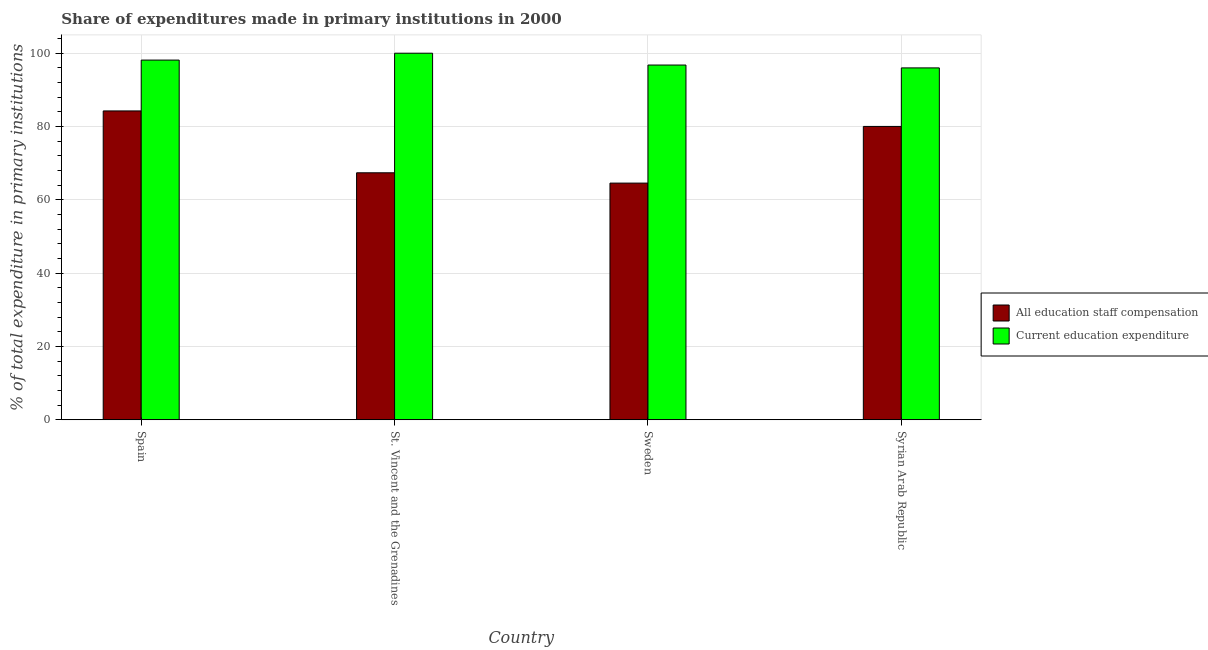Are the number of bars on each tick of the X-axis equal?
Your answer should be compact. Yes. What is the label of the 2nd group of bars from the left?
Provide a succinct answer. St. Vincent and the Grenadines. In how many cases, is the number of bars for a given country not equal to the number of legend labels?
Your answer should be very brief. 0. What is the expenditure in education in Spain?
Give a very brief answer. 98.12. Across all countries, what is the minimum expenditure in education?
Make the answer very short. 95.99. In which country was the expenditure in education maximum?
Give a very brief answer. St. Vincent and the Grenadines. In which country was the expenditure in education minimum?
Make the answer very short. Syrian Arab Republic. What is the total expenditure in staff compensation in the graph?
Your answer should be compact. 296.23. What is the difference between the expenditure in education in Spain and that in Sweden?
Make the answer very short. 1.35. What is the difference between the expenditure in staff compensation in St. Vincent and the Grenadines and the expenditure in education in Sweden?
Make the answer very short. -29.39. What is the average expenditure in staff compensation per country?
Keep it short and to the point. 74.06. What is the difference between the expenditure in education and expenditure in staff compensation in St. Vincent and the Grenadines?
Your response must be concise. 32.62. In how many countries, is the expenditure in education greater than 16 %?
Your answer should be very brief. 4. What is the ratio of the expenditure in staff compensation in St. Vincent and the Grenadines to that in Syrian Arab Republic?
Make the answer very short. 0.84. Is the expenditure in education in St. Vincent and the Grenadines less than that in Sweden?
Make the answer very short. No. Is the difference between the expenditure in education in Spain and Sweden greater than the difference between the expenditure in staff compensation in Spain and Sweden?
Provide a succinct answer. No. What is the difference between the highest and the second highest expenditure in staff compensation?
Offer a very short reply. 4.23. What is the difference between the highest and the lowest expenditure in staff compensation?
Make the answer very short. 19.69. In how many countries, is the expenditure in education greater than the average expenditure in education taken over all countries?
Ensure brevity in your answer.  2. What does the 1st bar from the left in Sweden represents?
Offer a very short reply. All education staff compensation. What does the 1st bar from the right in Spain represents?
Make the answer very short. Current education expenditure. Are the values on the major ticks of Y-axis written in scientific E-notation?
Your answer should be very brief. No. Where does the legend appear in the graph?
Provide a succinct answer. Center right. How many legend labels are there?
Keep it short and to the point. 2. What is the title of the graph?
Keep it short and to the point. Share of expenditures made in primary institutions in 2000. What is the label or title of the Y-axis?
Offer a very short reply. % of total expenditure in primary institutions. What is the % of total expenditure in primary institutions in All education staff compensation in Spain?
Ensure brevity in your answer.  84.26. What is the % of total expenditure in primary institutions in Current education expenditure in Spain?
Provide a succinct answer. 98.12. What is the % of total expenditure in primary institutions of All education staff compensation in St. Vincent and the Grenadines?
Your answer should be very brief. 67.38. What is the % of total expenditure in primary institutions of Current education expenditure in St. Vincent and the Grenadines?
Keep it short and to the point. 100. What is the % of total expenditure in primary institutions of All education staff compensation in Sweden?
Offer a very short reply. 64.57. What is the % of total expenditure in primary institutions in Current education expenditure in Sweden?
Your response must be concise. 96.77. What is the % of total expenditure in primary institutions in All education staff compensation in Syrian Arab Republic?
Provide a succinct answer. 80.03. What is the % of total expenditure in primary institutions of Current education expenditure in Syrian Arab Republic?
Offer a very short reply. 95.99. Across all countries, what is the maximum % of total expenditure in primary institutions in All education staff compensation?
Offer a terse response. 84.26. Across all countries, what is the minimum % of total expenditure in primary institutions in All education staff compensation?
Ensure brevity in your answer.  64.57. Across all countries, what is the minimum % of total expenditure in primary institutions in Current education expenditure?
Provide a short and direct response. 95.99. What is the total % of total expenditure in primary institutions of All education staff compensation in the graph?
Offer a terse response. 296.23. What is the total % of total expenditure in primary institutions in Current education expenditure in the graph?
Your response must be concise. 390.89. What is the difference between the % of total expenditure in primary institutions of All education staff compensation in Spain and that in St. Vincent and the Grenadines?
Give a very brief answer. 16.87. What is the difference between the % of total expenditure in primary institutions of Current education expenditure in Spain and that in St. Vincent and the Grenadines?
Your answer should be very brief. -1.88. What is the difference between the % of total expenditure in primary institutions of All education staff compensation in Spain and that in Sweden?
Keep it short and to the point. 19.69. What is the difference between the % of total expenditure in primary institutions of Current education expenditure in Spain and that in Sweden?
Provide a short and direct response. 1.35. What is the difference between the % of total expenditure in primary institutions in All education staff compensation in Spain and that in Syrian Arab Republic?
Your answer should be very brief. 4.23. What is the difference between the % of total expenditure in primary institutions in Current education expenditure in Spain and that in Syrian Arab Republic?
Keep it short and to the point. 2.13. What is the difference between the % of total expenditure in primary institutions in All education staff compensation in St. Vincent and the Grenadines and that in Sweden?
Keep it short and to the point. 2.81. What is the difference between the % of total expenditure in primary institutions in Current education expenditure in St. Vincent and the Grenadines and that in Sweden?
Ensure brevity in your answer.  3.23. What is the difference between the % of total expenditure in primary institutions of All education staff compensation in St. Vincent and the Grenadines and that in Syrian Arab Republic?
Provide a short and direct response. -12.65. What is the difference between the % of total expenditure in primary institutions in Current education expenditure in St. Vincent and the Grenadines and that in Syrian Arab Republic?
Provide a short and direct response. 4.01. What is the difference between the % of total expenditure in primary institutions in All education staff compensation in Sweden and that in Syrian Arab Republic?
Your answer should be very brief. -15.46. What is the difference between the % of total expenditure in primary institutions of Current education expenditure in Sweden and that in Syrian Arab Republic?
Offer a terse response. 0.78. What is the difference between the % of total expenditure in primary institutions in All education staff compensation in Spain and the % of total expenditure in primary institutions in Current education expenditure in St. Vincent and the Grenadines?
Ensure brevity in your answer.  -15.74. What is the difference between the % of total expenditure in primary institutions of All education staff compensation in Spain and the % of total expenditure in primary institutions of Current education expenditure in Sweden?
Make the answer very short. -12.52. What is the difference between the % of total expenditure in primary institutions in All education staff compensation in Spain and the % of total expenditure in primary institutions in Current education expenditure in Syrian Arab Republic?
Keep it short and to the point. -11.74. What is the difference between the % of total expenditure in primary institutions of All education staff compensation in St. Vincent and the Grenadines and the % of total expenditure in primary institutions of Current education expenditure in Sweden?
Offer a terse response. -29.39. What is the difference between the % of total expenditure in primary institutions of All education staff compensation in St. Vincent and the Grenadines and the % of total expenditure in primary institutions of Current education expenditure in Syrian Arab Republic?
Your answer should be compact. -28.61. What is the difference between the % of total expenditure in primary institutions in All education staff compensation in Sweden and the % of total expenditure in primary institutions in Current education expenditure in Syrian Arab Republic?
Make the answer very short. -31.43. What is the average % of total expenditure in primary institutions in All education staff compensation per country?
Your answer should be compact. 74.06. What is the average % of total expenditure in primary institutions in Current education expenditure per country?
Your answer should be compact. 97.72. What is the difference between the % of total expenditure in primary institutions in All education staff compensation and % of total expenditure in primary institutions in Current education expenditure in Spain?
Offer a very short reply. -13.87. What is the difference between the % of total expenditure in primary institutions of All education staff compensation and % of total expenditure in primary institutions of Current education expenditure in St. Vincent and the Grenadines?
Give a very brief answer. -32.62. What is the difference between the % of total expenditure in primary institutions in All education staff compensation and % of total expenditure in primary institutions in Current education expenditure in Sweden?
Give a very brief answer. -32.2. What is the difference between the % of total expenditure in primary institutions in All education staff compensation and % of total expenditure in primary institutions in Current education expenditure in Syrian Arab Republic?
Give a very brief answer. -15.97. What is the ratio of the % of total expenditure in primary institutions in All education staff compensation in Spain to that in St. Vincent and the Grenadines?
Offer a very short reply. 1.25. What is the ratio of the % of total expenditure in primary institutions in Current education expenditure in Spain to that in St. Vincent and the Grenadines?
Offer a very short reply. 0.98. What is the ratio of the % of total expenditure in primary institutions of All education staff compensation in Spain to that in Sweden?
Your answer should be very brief. 1.3. What is the ratio of the % of total expenditure in primary institutions in Current education expenditure in Spain to that in Sweden?
Make the answer very short. 1.01. What is the ratio of the % of total expenditure in primary institutions of All education staff compensation in Spain to that in Syrian Arab Republic?
Your response must be concise. 1.05. What is the ratio of the % of total expenditure in primary institutions of Current education expenditure in Spain to that in Syrian Arab Republic?
Make the answer very short. 1.02. What is the ratio of the % of total expenditure in primary institutions of All education staff compensation in St. Vincent and the Grenadines to that in Sweden?
Give a very brief answer. 1.04. What is the ratio of the % of total expenditure in primary institutions in Current education expenditure in St. Vincent and the Grenadines to that in Sweden?
Provide a short and direct response. 1.03. What is the ratio of the % of total expenditure in primary institutions of All education staff compensation in St. Vincent and the Grenadines to that in Syrian Arab Republic?
Provide a succinct answer. 0.84. What is the ratio of the % of total expenditure in primary institutions in Current education expenditure in St. Vincent and the Grenadines to that in Syrian Arab Republic?
Provide a succinct answer. 1.04. What is the ratio of the % of total expenditure in primary institutions in All education staff compensation in Sweden to that in Syrian Arab Republic?
Your answer should be very brief. 0.81. What is the ratio of the % of total expenditure in primary institutions of Current education expenditure in Sweden to that in Syrian Arab Republic?
Offer a terse response. 1.01. What is the difference between the highest and the second highest % of total expenditure in primary institutions of All education staff compensation?
Offer a terse response. 4.23. What is the difference between the highest and the second highest % of total expenditure in primary institutions in Current education expenditure?
Offer a terse response. 1.88. What is the difference between the highest and the lowest % of total expenditure in primary institutions in All education staff compensation?
Provide a succinct answer. 19.69. What is the difference between the highest and the lowest % of total expenditure in primary institutions of Current education expenditure?
Your answer should be very brief. 4.01. 